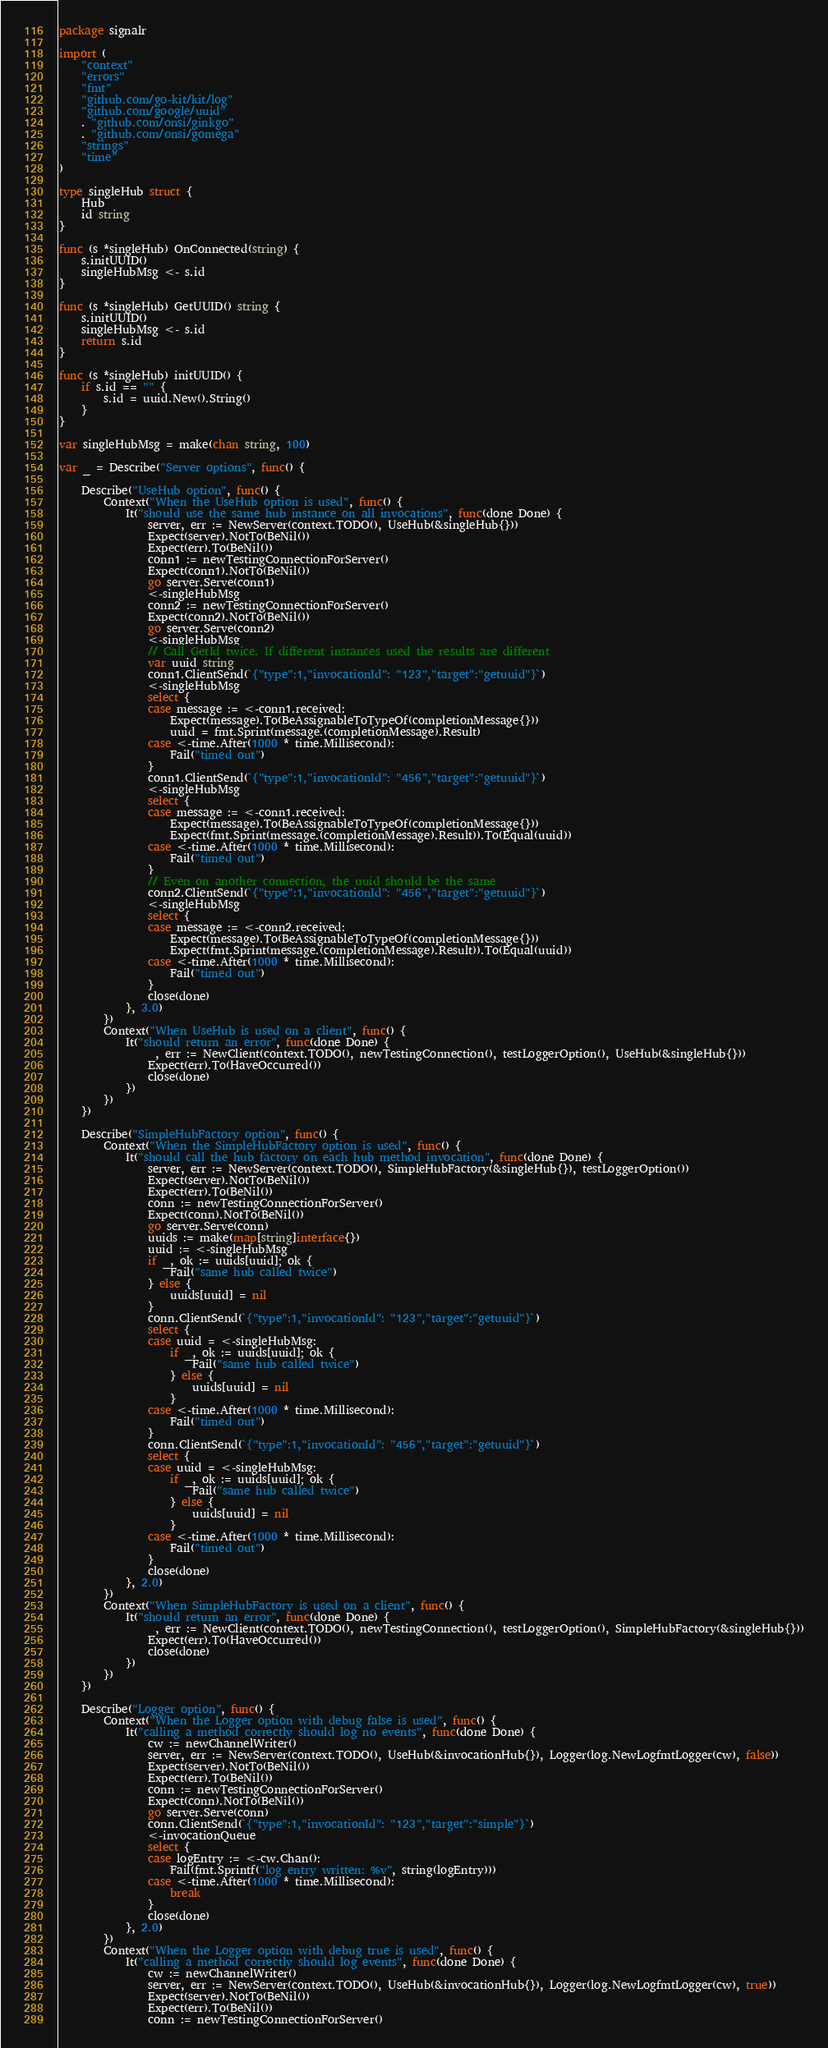<code> <loc_0><loc_0><loc_500><loc_500><_Go_>package signalr

import (
	"context"
	"errors"
	"fmt"
	"github.com/go-kit/kit/log"
	"github.com/google/uuid"
	. "github.com/onsi/ginkgo"
	. "github.com/onsi/gomega"
	"strings"
	"time"
)

type singleHub struct {
	Hub
	id string
}

func (s *singleHub) OnConnected(string) {
	s.initUUID()
	singleHubMsg <- s.id
}

func (s *singleHub) GetUUID() string {
	s.initUUID()
	singleHubMsg <- s.id
	return s.id
}

func (s *singleHub) initUUID() {
	if s.id == "" {
		s.id = uuid.New().String()
	}
}

var singleHubMsg = make(chan string, 100)

var _ = Describe("Server options", func() {

	Describe("UseHub option", func() {
		Context("When the UseHub option is used", func() {
			It("should use the same hub instance on all invocations", func(done Done) {
				server, err := NewServer(context.TODO(), UseHub(&singleHub{}))
				Expect(server).NotTo(BeNil())
				Expect(err).To(BeNil())
				conn1 := newTestingConnectionForServer()
				Expect(conn1).NotTo(BeNil())
				go server.Serve(conn1)
				<-singleHubMsg
				conn2 := newTestingConnectionForServer()
				Expect(conn2).NotTo(BeNil())
				go server.Serve(conn2)
				<-singleHubMsg
				// Call GetId twice. If different instances used the results are different
				var uuid string
				conn1.ClientSend(`{"type":1,"invocationId": "123","target":"getuuid"}`)
				<-singleHubMsg
				select {
				case message := <-conn1.received:
					Expect(message).To(BeAssignableToTypeOf(completionMessage{}))
					uuid = fmt.Sprint(message.(completionMessage).Result)
				case <-time.After(1000 * time.Millisecond):
					Fail("timed out")
				}
				conn1.ClientSend(`{"type":1,"invocationId": "456","target":"getuuid"}`)
				<-singleHubMsg
				select {
				case message := <-conn1.received:
					Expect(message).To(BeAssignableToTypeOf(completionMessage{}))
					Expect(fmt.Sprint(message.(completionMessage).Result)).To(Equal(uuid))
				case <-time.After(1000 * time.Millisecond):
					Fail("timed out")
				}
				// Even on another connection, the uuid should be the same
				conn2.ClientSend(`{"type":1,"invocationId": "456","target":"getuuid"}`)
				<-singleHubMsg
				select {
				case message := <-conn2.received:
					Expect(message).To(BeAssignableToTypeOf(completionMessage{}))
					Expect(fmt.Sprint(message.(completionMessage).Result)).To(Equal(uuid))
				case <-time.After(1000 * time.Millisecond):
					Fail("timed out")
				}
				close(done)
			}, 3.0)
		})
		Context("When UseHub is used on a client", func() {
			It("should return an error", func(done Done) {
				_, err := NewClient(context.TODO(), newTestingConnection(), testLoggerOption(), UseHub(&singleHub{}))
				Expect(err).To(HaveOccurred())
				close(done)
			})
		})
	})

	Describe("SimpleHubFactory option", func() {
		Context("When the SimpleHubFactory option is used", func() {
			It("should call the hub factory on each hub method invocation", func(done Done) {
				server, err := NewServer(context.TODO(), SimpleHubFactory(&singleHub{}), testLoggerOption())
				Expect(server).NotTo(BeNil())
				Expect(err).To(BeNil())
				conn := newTestingConnectionForServer()
				Expect(conn).NotTo(BeNil())
				go server.Serve(conn)
				uuids := make(map[string]interface{})
				uuid := <-singleHubMsg
				if _, ok := uuids[uuid]; ok {
					Fail("same hub called twice")
				} else {
					uuids[uuid] = nil
				}
				conn.ClientSend(`{"type":1,"invocationId": "123","target":"getuuid"}`)
				select {
				case uuid = <-singleHubMsg:
					if _, ok := uuids[uuid]; ok {
						Fail("same hub called twice")
					} else {
						uuids[uuid] = nil
					}
				case <-time.After(1000 * time.Millisecond):
					Fail("timed out")
				}
				conn.ClientSend(`{"type":1,"invocationId": "456","target":"getuuid"}`)
				select {
				case uuid = <-singleHubMsg:
					if _, ok := uuids[uuid]; ok {
						Fail("same hub called twice")
					} else {
						uuids[uuid] = nil
					}
				case <-time.After(1000 * time.Millisecond):
					Fail("timed out")
				}
				close(done)
			}, 2.0)
		})
		Context("When SimpleHubFactory is used on a client", func() {
			It("should return an error", func(done Done) {
				_, err := NewClient(context.TODO(), newTestingConnection(), testLoggerOption(), SimpleHubFactory(&singleHub{}))
				Expect(err).To(HaveOccurred())
				close(done)
			})
		})
	})

	Describe("Logger option", func() {
		Context("When the Logger option with debug false is used", func() {
			It("calling a method correctly should log no events", func(done Done) {
				cw := newChannelWriter()
				server, err := NewServer(context.TODO(), UseHub(&invocationHub{}), Logger(log.NewLogfmtLogger(cw), false))
				Expect(server).NotTo(BeNil())
				Expect(err).To(BeNil())
				conn := newTestingConnectionForServer()
				Expect(conn).NotTo(BeNil())
				go server.Serve(conn)
				conn.ClientSend(`{"type":1,"invocationId": "123","target":"simple"}`)
				<-invocationQueue
				select {
				case logEntry := <-cw.Chan():
					Fail(fmt.Sprintf("log entry written: %v", string(logEntry)))
				case <-time.After(1000 * time.Millisecond):
					break
				}
				close(done)
			}, 2.0)
		})
		Context("When the Logger option with debug true is used", func() {
			It("calling a method correctly should log events", func(done Done) {
				cw := newChannelWriter()
				server, err := NewServer(context.TODO(), UseHub(&invocationHub{}), Logger(log.NewLogfmtLogger(cw), true))
				Expect(server).NotTo(BeNil())
				Expect(err).To(BeNil())
				conn := newTestingConnectionForServer()</code> 